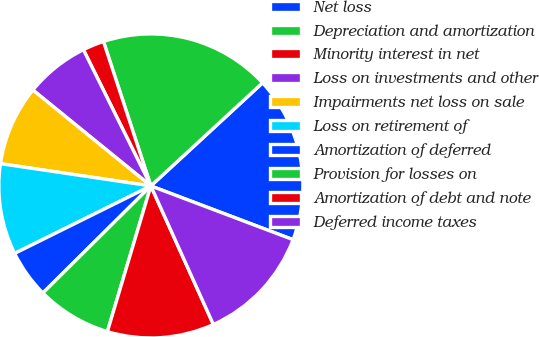Convert chart. <chart><loc_0><loc_0><loc_500><loc_500><pie_chart><fcel>Net loss<fcel>Depreciation and amortization<fcel>Minority interest in net<fcel>Loss on investments and other<fcel>Impairments net loss on sale<fcel>Loss on retirement of<fcel>Amortization of deferred<fcel>Provision for losses on<fcel>Amortization of debt and note<fcel>Deferred income taxes<nl><fcel>17.61%<fcel>18.18%<fcel>2.27%<fcel>6.82%<fcel>8.52%<fcel>9.66%<fcel>5.11%<fcel>7.95%<fcel>11.36%<fcel>12.5%<nl></chart> 